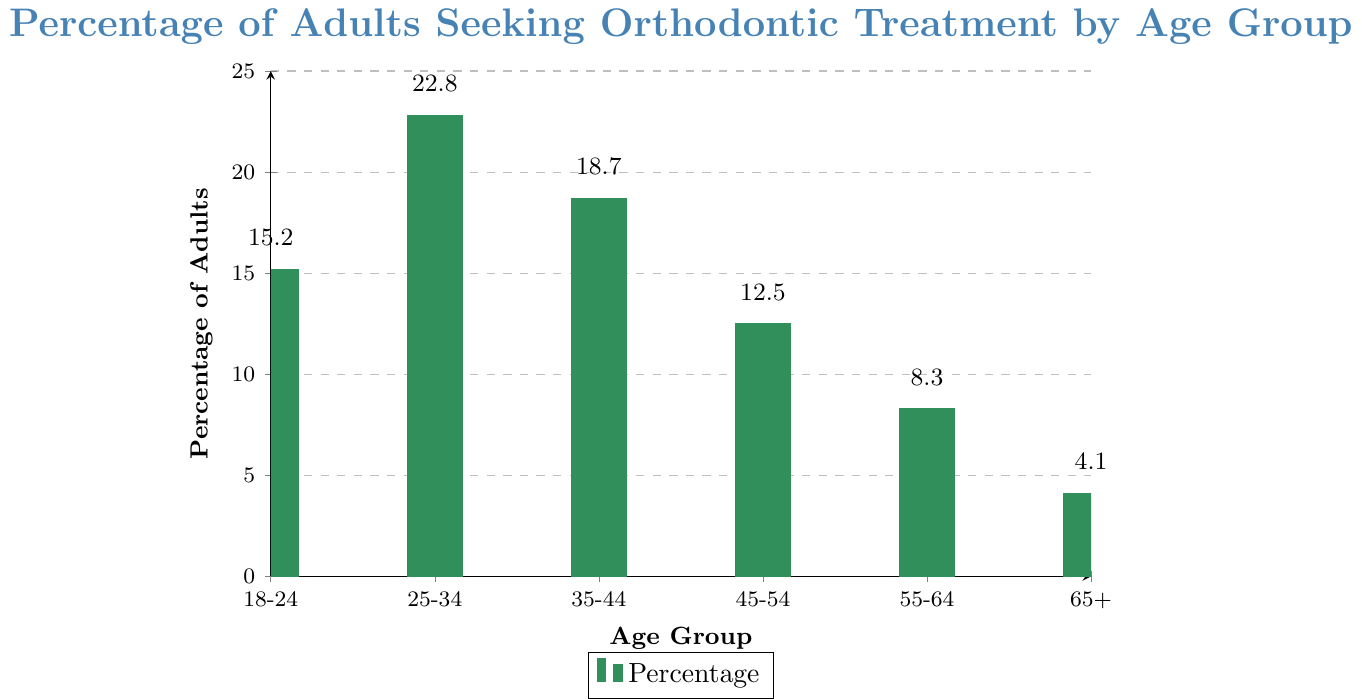What's the percentage of adults seeking orthodontic treatment in the 25-34 age group? The bar chart shows the percentage values for each age group. For the 25-34 age group, locate the bar labeled 25-34 and read its height on the y-axis, which is 22.8.
Answer: 22.8 How does the percentage of adults seeking treatment in the 55-64 group compare to the 65+ group? To compare, find the bars labeled 55-64 and 65+. The heights show 8.3% for 55-64 and 4.1% for 65+. Comparing these, 8.3% is higher than 4.1%.
Answer: 8.3% is higher than 4.1% What is the average percentage of adults seeking orthodontic treatment across all age groups? Sum the percentages for all groups (15.2 + 22.8 + 18.7 + 12.5 + 8.3 + 4.1) which equals 81.6. Divide by the number of age groups, which is 6. So, 81.6 / 6 = 13.6.
Answer: 13.6 Which age group has the lowest percentage of adults seeking orthodontic treatment? Examine the bars for their heights. The smallest bar corresponds to the 65+ age group at 4.1%.
Answer: 65+ By how much does the 35-44 group's percentage exceed the 45-54 group's percentage? Find the percentages: 18.7 for 35-44 and 12.5 for 45-54. Subtract 12.5 from 18.7, which equals 6.2.
Answer: 6.2 Is the percentage of adults seeking treatment in the 18-24 group higher or lower than the 55-64 group? Compare the heights of the bars labeled 18-24 (15.2) and 55-64 (8.3). Since 15.2 is greater than 8.3, 18-24 is higher.
Answer: Higher What's the combined percentage of adults seeking orthodontic treatment in age groups 25-34 and 35-44? Sum the percentages of the two age groups: 22.8 (25-34) + 18.7 (35-44) = 41.5.
Answer: 41.5 What is the difference between the highest and the lowest percentages? The highest percentage is 22.8 (25-34), and the lowest is 4.1 (65+). Subtract 4.1 from 22.8, which is 18.7.
Answer: 18.7 What is the total percentage of adults seeking orthodontic treatment in the age groups above 45? Sum the percentages of the age groups 45-54 (12.5), 55-64 (8.3), and 65+ (4.1). 12.5 + 8.3 + 4.1 = 24.9.
Answer: 24.9 Which age group shows a significant drop in percentage compared to the preceding group? Look for the age group with a noticeable decrease in height from the previous group. The 55-64 group has 8.3%, dropping from 12.5% in the 45-54 group, a decrease of 4.2.
Answer: 55-64 